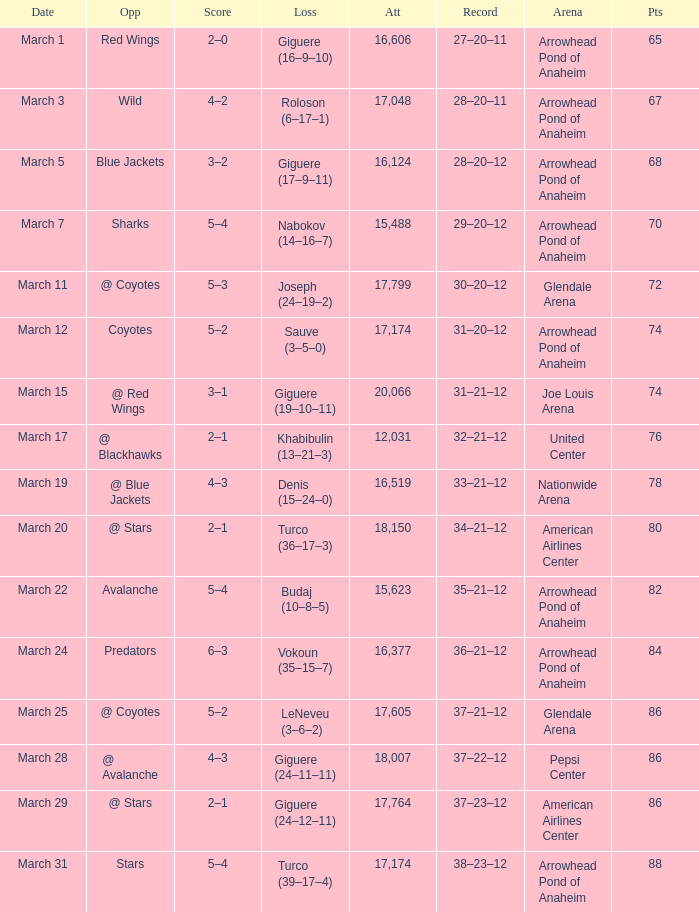What is the game attendance where the record is 37-21-12 and the points are below 86? None. 